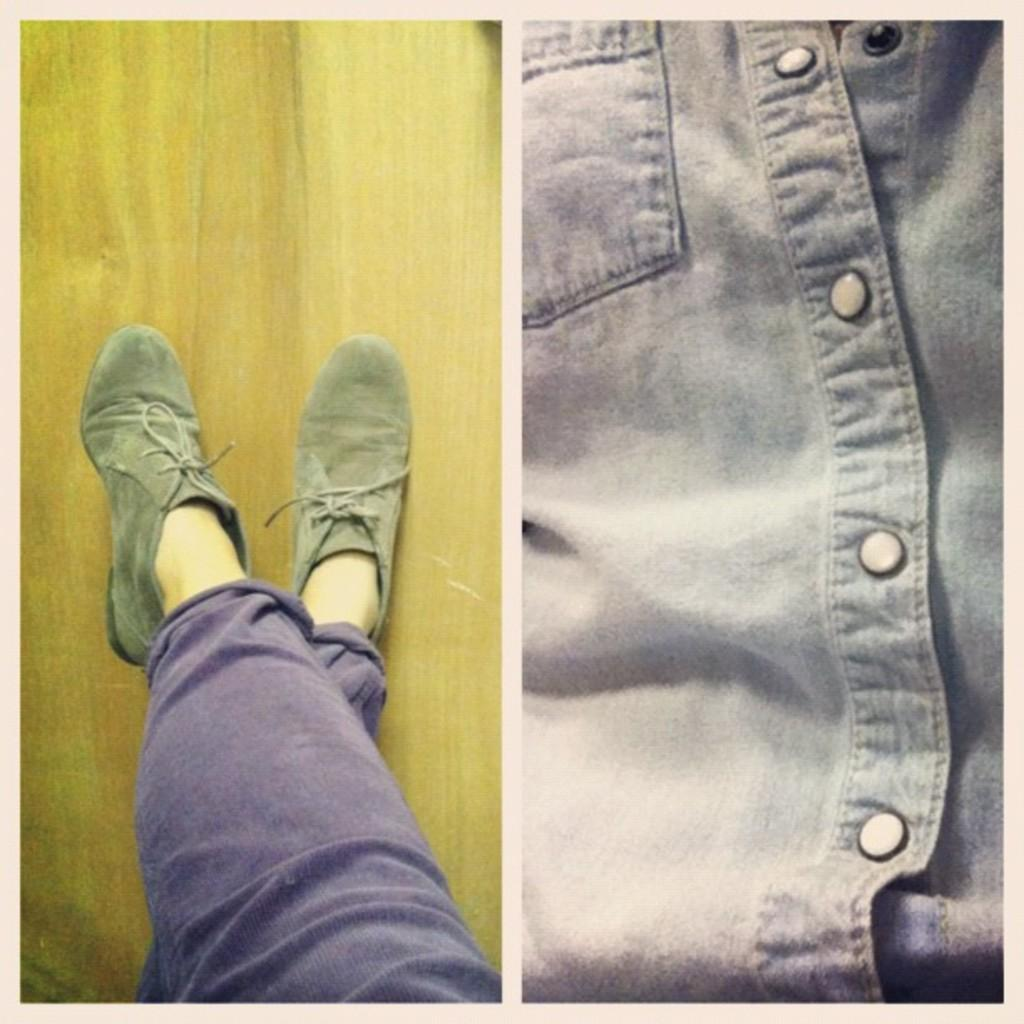What type of artwork is the image? The image is a collage. What can be seen on the left side of the collage? The left side of the image shows a person's legs with shoes on a surface. What is depicted on the right side of the collage? The right side of the image shows a shirt. What type of balls can be seen bouncing on the surface in the image? There are no balls present in the image; it shows a person's legs with shoes on a surface and a shirt on the right side. 